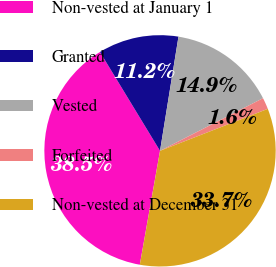Convert chart to OTSL. <chart><loc_0><loc_0><loc_500><loc_500><pie_chart><fcel>Non-vested at January 1<fcel>Granted<fcel>Vested<fcel>Forfeited<fcel>Non-vested at December 31<nl><fcel>38.52%<fcel>11.24%<fcel>14.93%<fcel>1.61%<fcel>33.71%<nl></chart> 